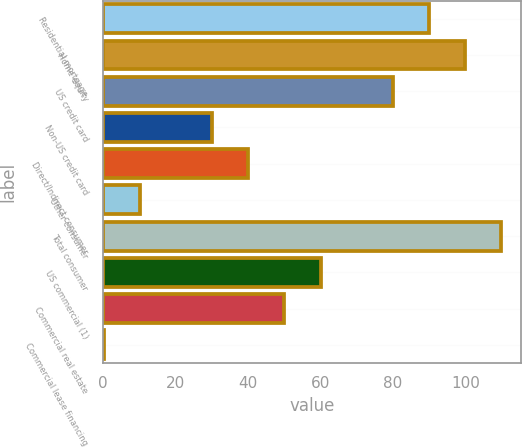<chart> <loc_0><loc_0><loc_500><loc_500><bar_chart><fcel>Residential mortgage<fcel>Home equity<fcel>US credit card<fcel>Non-US credit card<fcel>Direct/Indirect consumer<fcel>Other consumer<fcel>Total consumer<fcel>US commercial (1)<fcel>Commercial real estate<fcel>Commercial lease financing<nl><fcel>90<fcel>99.97<fcel>80.03<fcel>30.18<fcel>40.15<fcel>10.24<fcel>109.94<fcel>60.09<fcel>50.12<fcel>0.27<nl></chart> 